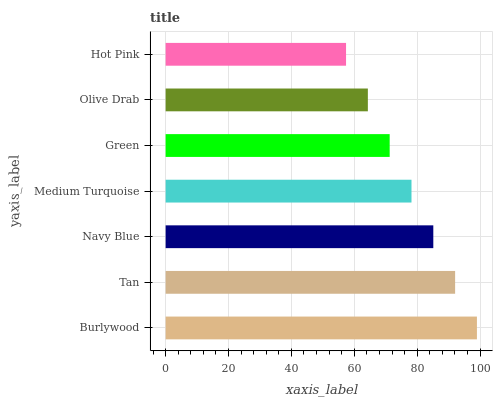Is Hot Pink the minimum?
Answer yes or no. Yes. Is Burlywood the maximum?
Answer yes or no. Yes. Is Tan the minimum?
Answer yes or no. No. Is Tan the maximum?
Answer yes or no. No. Is Burlywood greater than Tan?
Answer yes or no. Yes. Is Tan less than Burlywood?
Answer yes or no. Yes. Is Tan greater than Burlywood?
Answer yes or no. No. Is Burlywood less than Tan?
Answer yes or no. No. Is Medium Turquoise the high median?
Answer yes or no. Yes. Is Medium Turquoise the low median?
Answer yes or no. Yes. Is Hot Pink the high median?
Answer yes or no. No. Is Olive Drab the low median?
Answer yes or no. No. 